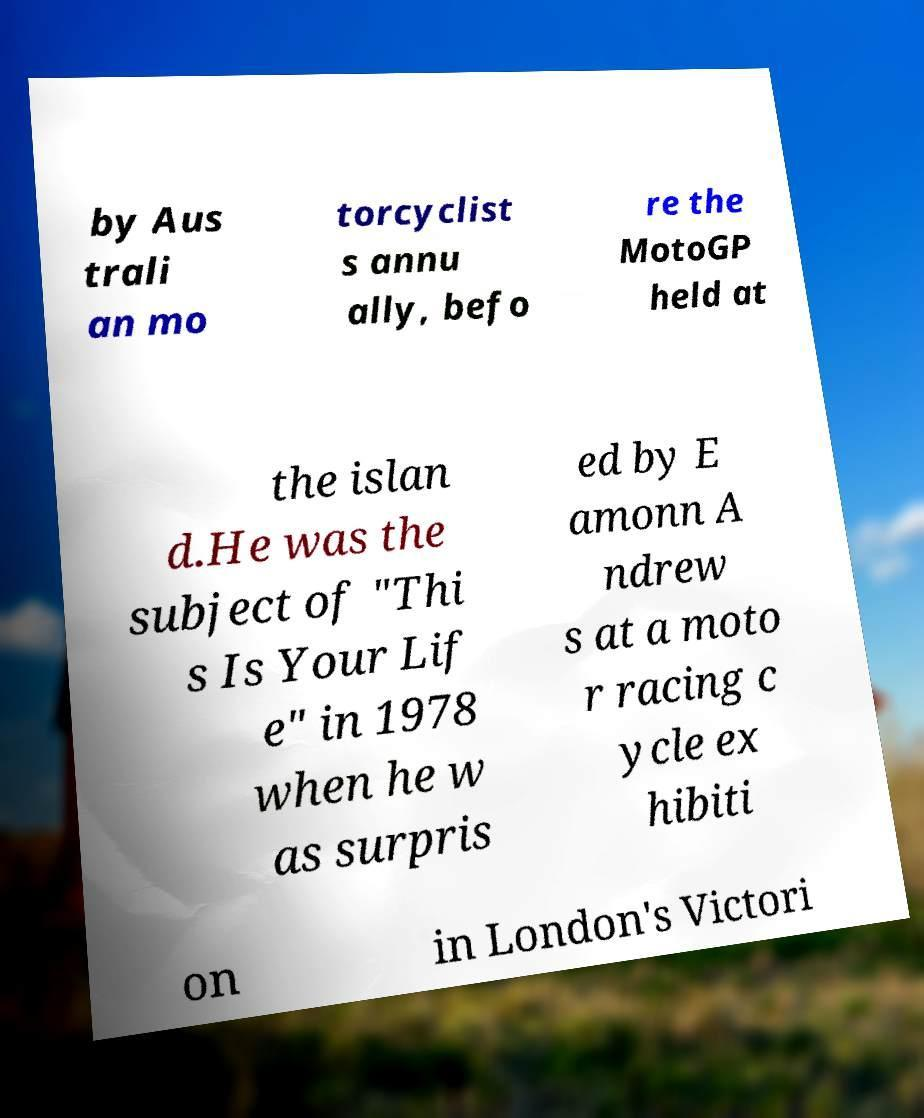I need the written content from this picture converted into text. Can you do that? by Aus trali an mo torcyclist s annu ally, befo re the MotoGP held at the islan d.He was the subject of "Thi s Is Your Lif e" in 1978 when he w as surpris ed by E amonn A ndrew s at a moto r racing c ycle ex hibiti on in London's Victori 